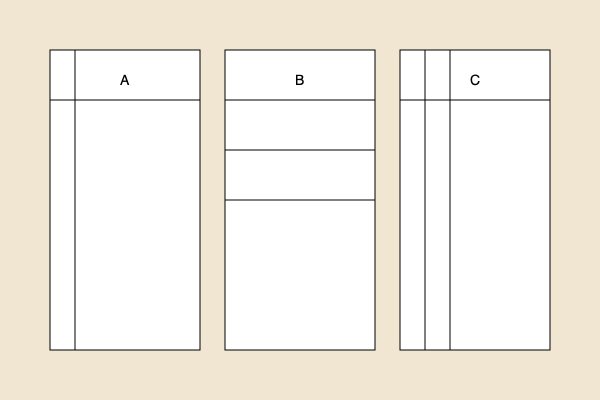Examining the layout of these three ancient manuscript pages (A, B, and C), which manuscript is most likely to be a liturgical text used in religious ceremonies? To determine which manuscript is most likely a liturgical text, we need to analyze the layout and structure of each:

1. Manuscript A:
   - Has a single vertical line dividing the page into two columns
   - Contains a horizontal line near the top, possibly for a title or header
   - This layout is common in many types of texts, including historical documents or literary works

2. Manuscript B:
   - Features multiple horizontal lines dividing the page into sections
   - No vertical divisions
   - This structure is often seen in legal documents, contracts, or lists

3. Manuscript C:
   - Has two vertical lines dividing the page into three columns
   - Contains a horizontal line near the top, possibly for a title or header
   - This layout is characteristic of liturgical texts, particularly those used in religious ceremonies

Liturgical texts often have a three-column layout for several reasons:
- The central column typically contains the main text
- The left column might include rubrics or instructions for the ceremony
- The right column could contain musical notations, responses, or additional commentary

The three-column structure allows for easy reference during ceremonies, enabling the officiant to navigate between the main text, instructions, and musical elements efficiently.

Given these characteristics, Manuscript C is the most likely candidate for a liturgical text used in religious ceremonies.
Answer: Manuscript C 